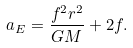<formula> <loc_0><loc_0><loc_500><loc_500>a _ { E } = \frac { f ^ { 2 } r ^ { 2 } } { G M } + 2 f .</formula> 